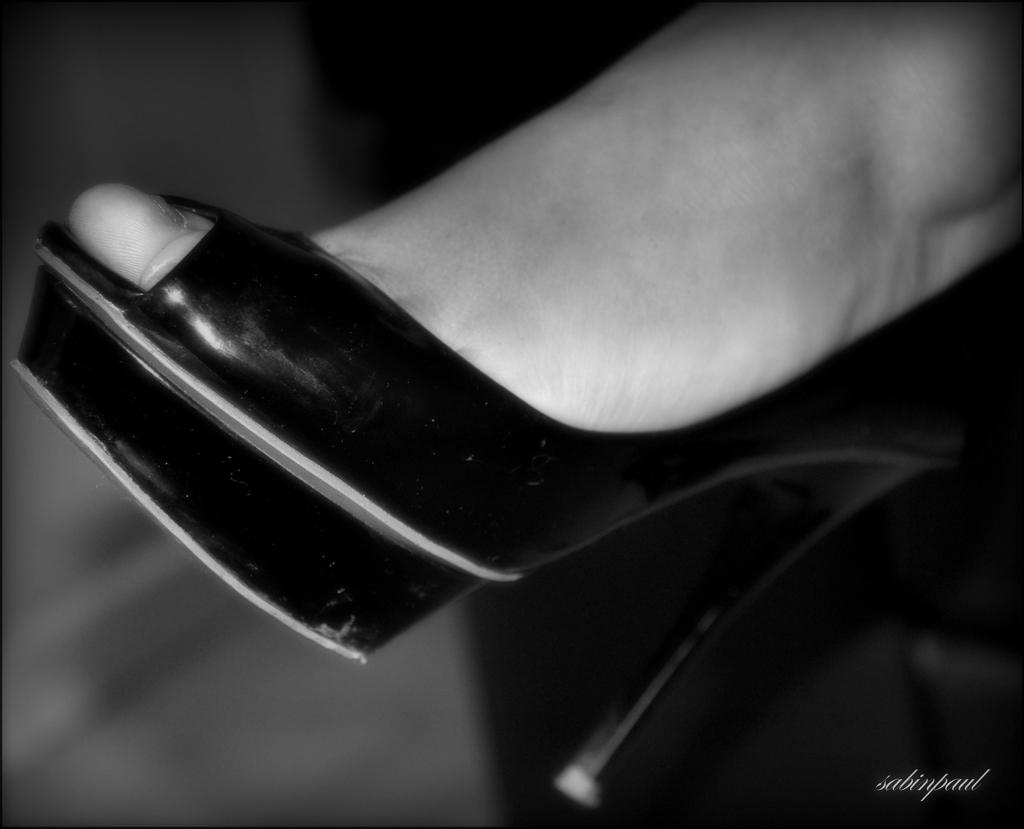What part of a person can be seen in the image? There is a leg of a person in the image. What type of footwear is the person wearing? The person is wearing a sandal. Is there any text or marking visible in the image? Yes, there is a watermark at the bottom right side of the image. What type of feeling does the person in the image have towards the company of frogs? There is no information about the person's feelings or the presence of frogs in the image. 